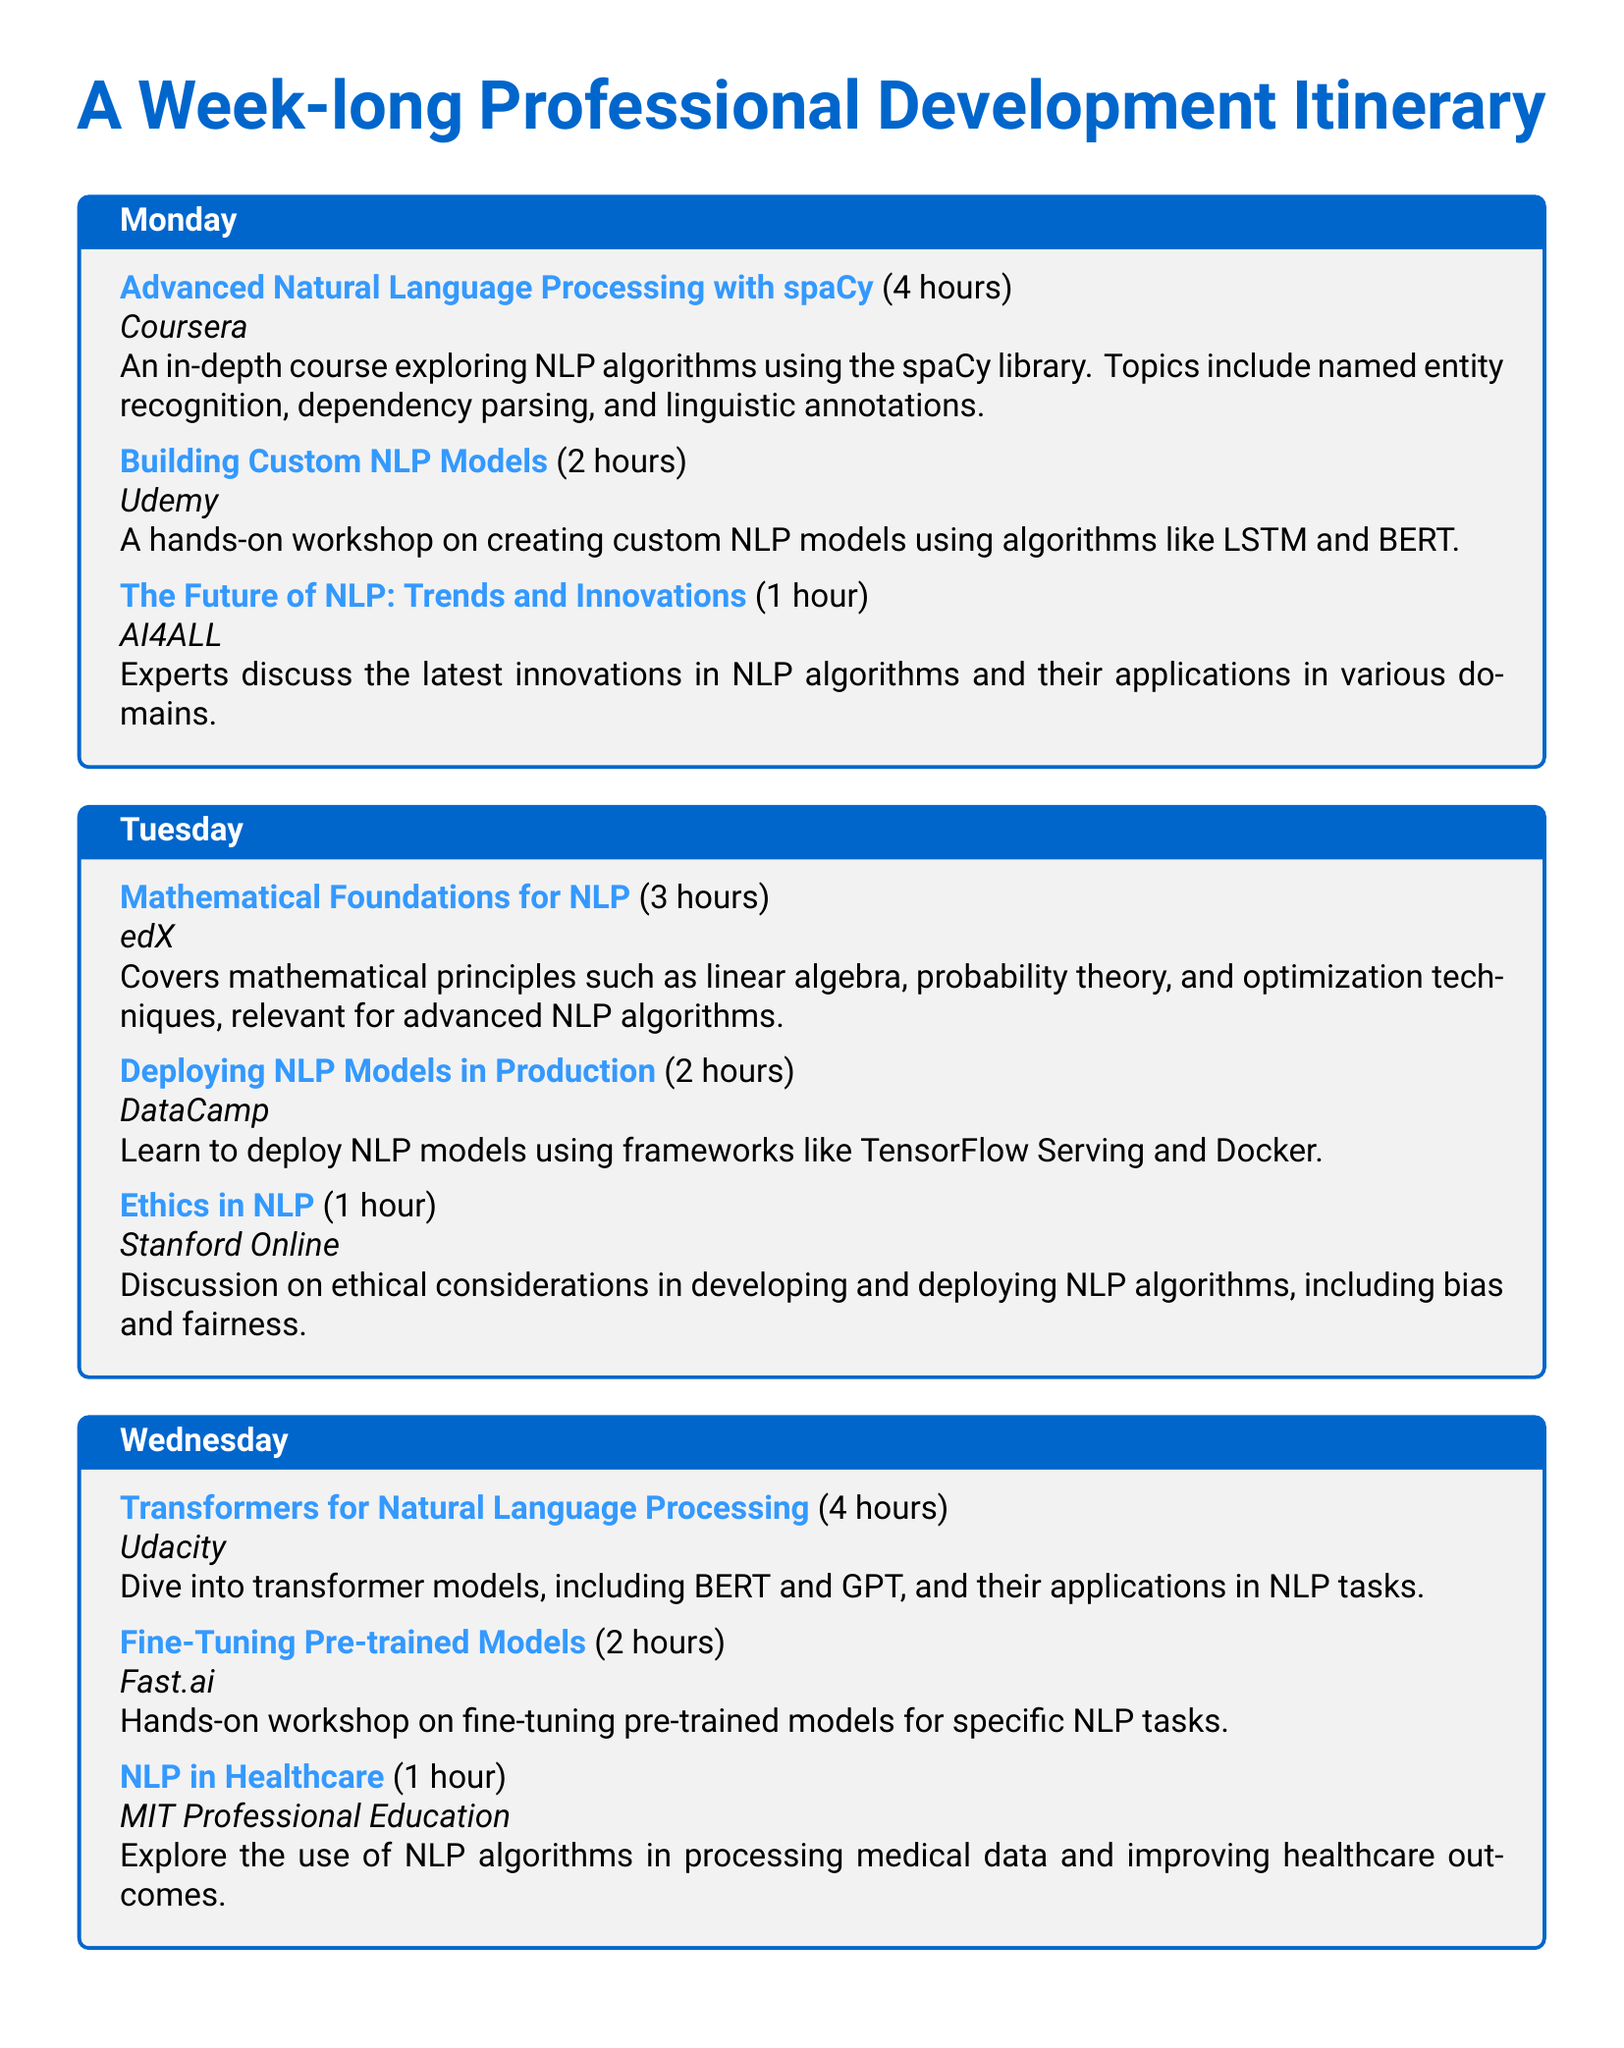what is the title of the course on Monday focused on spaCy? The title of the course is "Advanced Natural Language Processing with spaCy."
Answer: Advanced Natural Language Processing with spaCy how long is the workshop on Building Custom NLP Models? The duration of the workshop is 2 hours.
Answer: 2 hours which day includes a session on Ethics in NLP? The session on Ethics in NLP is scheduled for Tuesday.
Answer: Tuesday how many hours is the course on Deep Learning for NLP? The course on Deep Learning for NLP is 4 hours long.
Answer: 4 hours name one of the platforms offering a workshop on fine-tuning pre-trained models. The platform offering a workshop on fine-tuning pre-trained models is Fast.ai.
Answer: Fast.ai what topic is covered in the session titled "NLP in Healthcare"? The session explores the use of NLP algorithms in processing medical data and improving healthcare outcomes.
Answer: processing medical data and improving healthcare outcomes which event on Wednesday focuses on transformer models? The event focusing on transformer models is "Transformers for Natural Language Processing."
Answer: Transformers for Natural Language Processing how many events are scheduled for Thursday? There are 3 events scheduled for Thursday.
Answer: 3 events what is the duration of the event on Industry Applications of NLP? The duration of the event on Industry Applications of NLP is 1 hour.
Answer: 1 hour 